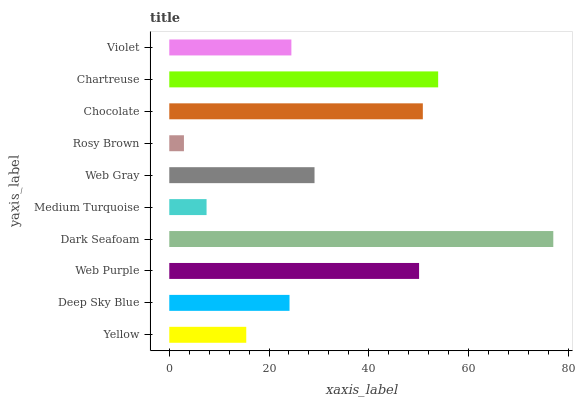Is Rosy Brown the minimum?
Answer yes or no. Yes. Is Dark Seafoam the maximum?
Answer yes or no. Yes. Is Deep Sky Blue the minimum?
Answer yes or no. No. Is Deep Sky Blue the maximum?
Answer yes or no. No. Is Deep Sky Blue greater than Yellow?
Answer yes or no. Yes. Is Yellow less than Deep Sky Blue?
Answer yes or no. Yes. Is Yellow greater than Deep Sky Blue?
Answer yes or no. No. Is Deep Sky Blue less than Yellow?
Answer yes or no. No. Is Web Gray the high median?
Answer yes or no. Yes. Is Violet the low median?
Answer yes or no. Yes. Is Violet the high median?
Answer yes or no. No. Is Deep Sky Blue the low median?
Answer yes or no. No. 